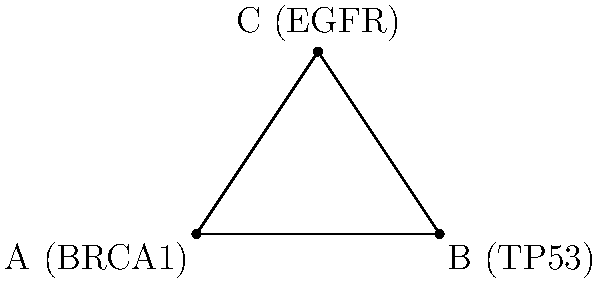In a genomic coordinate system, three gene locations are plotted: BRCA1 at (0,0), TP53 at (4,0), and EGFR at (2,3). What is the measure of the angle $\theta$ formed at the BRCA1 locus between the lines connecting BRCA1 to TP53 and BRCA1 to EGFR? Round your answer to the nearest degree. To find the angle $\theta$, we can use the law of cosines:

1) First, calculate the distances between the points:
   AB = $\sqrt{(4-0)^2 + (0-0)^2} = 4$
   AC = $\sqrt{(2-0)^2 + (3-0)^2} = \sqrt{13}$
   BC = $\sqrt{(2-4)^2 + (3-0)^2} = \sqrt{13}$

2) Apply the law of cosines:
   $\cos(\theta) = \frac{AB^2 + AC^2 - BC^2}{2(AB)(AC)}$

3) Substitute the values:
   $\cos(\theta) = \frac{4^2 + (\sqrt{13})^2 - (\sqrt{13})^2}{2(4)(\sqrt{13})}$

4) Simplify:
   $\cos(\theta) = \frac{16}{8\sqrt{13}} = \frac{2}{\sqrt{13}}$

5) Take the inverse cosine (arccos) of both sides:
   $\theta = \arccos(\frac{2}{\sqrt{13}})$

6) Calculate and round to the nearest degree:
   $\theta \approx 56.31°$, which rounds to 56°

This angle could indicate potential regulatory relationships or interactions between these genes in the context of their spatial arrangement in the genome.
Answer: 56° 